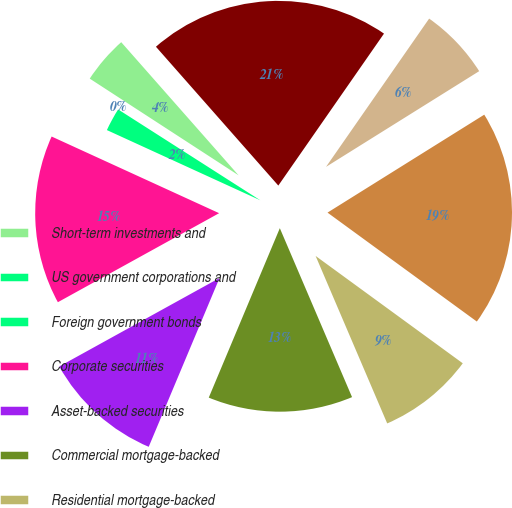Convert chart to OTSL. <chart><loc_0><loc_0><loc_500><loc_500><pie_chart><fcel>Short-term investments and<fcel>US government corporations and<fcel>Foreign government bonds<fcel>Corporate securities<fcel>Asset-backed securities<fcel>Commercial mortgage-backed<fcel>Residential mortgage-backed<fcel>Total fixed maturities<fcel>Equity securities<fcel>Total trading account assets<nl><fcel>4.33%<fcel>0.12%<fcel>2.22%<fcel>14.86%<fcel>10.65%<fcel>12.75%<fcel>8.54%<fcel>18.92%<fcel>6.44%<fcel>21.17%<nl></chart> 